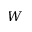Convert formula to latex. <formula><loc_0><loc_0><loc_500><loc_500>W</formula> 